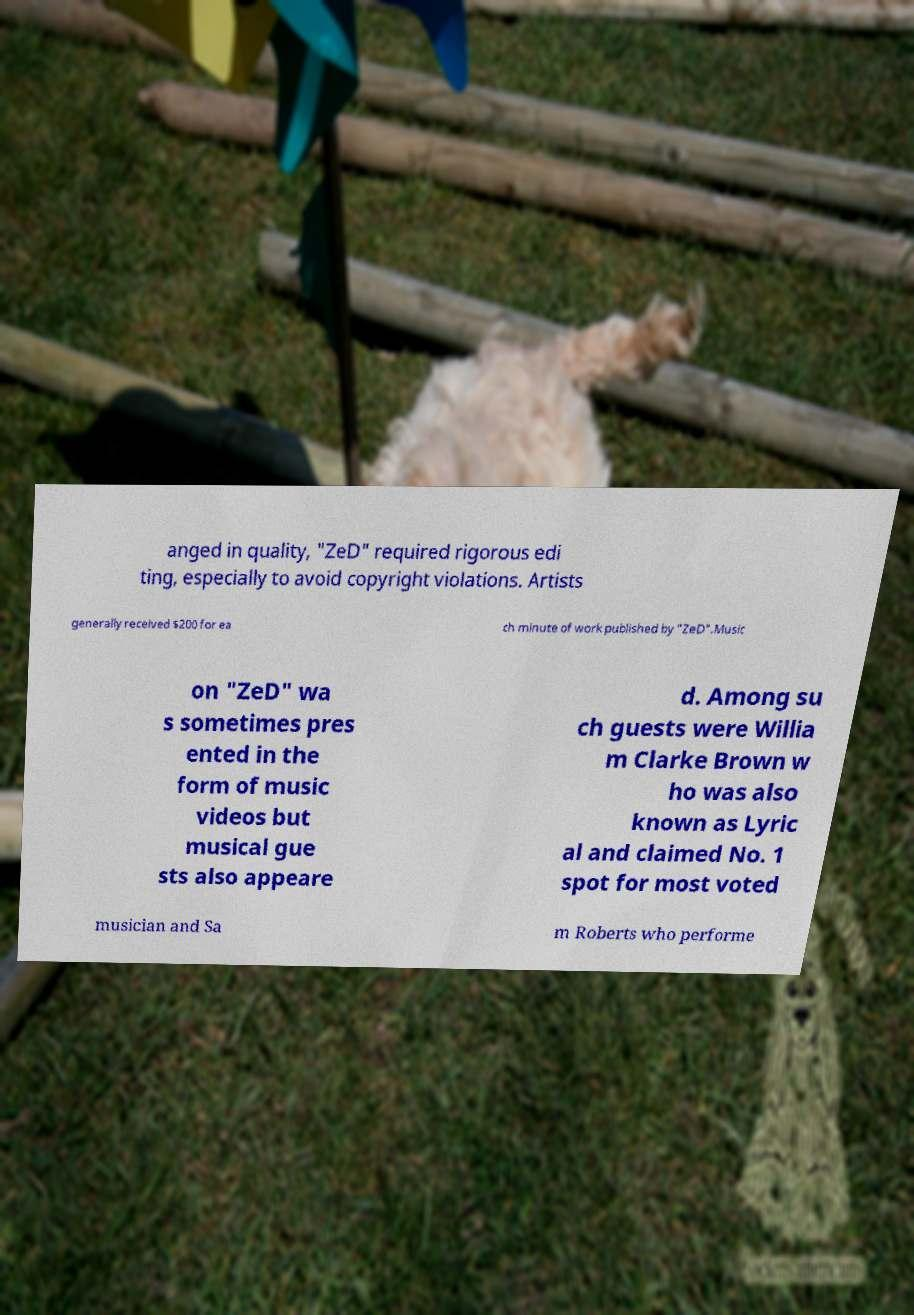Can you read and provide the text displayed in the image?This photo seems to have some interesting text. Can you extract and type it out for me? anged in quality, "ZeD" required rigorous edi ting, especially to avoid copyright violations. Artists generally received $200 for ea ch minute of work published by "ZeD".Music on "ZeD" wa s sometimes pres ented in the form of music videos but musical gue sts also appeare d. Among su ch guests were Willia m Clarke Brown w ho was also known as Lyric al and claimed No. 1 spot for most voted musician and Sa m Roberts who performe 